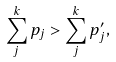Convert formula to latex. <formula><loc_0><loc_0><loc_500><loc_500>\sum _ { j } ^ { k } p _ { j } > \sum _ { j } ^ { k } p _ { j } ^ { \prime } ,</formula> 